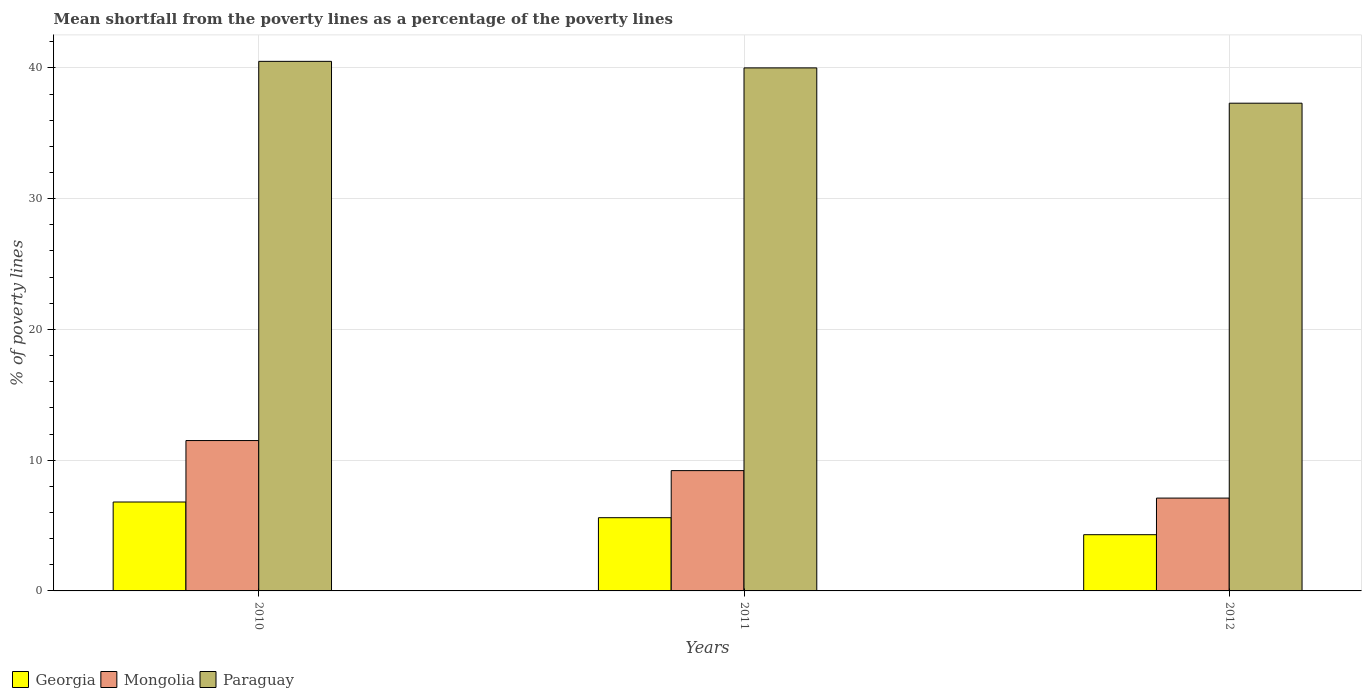How many different coloured bars are there?
Make the answer very short. 3. How many bars are there on the 1st tick from the left?
Give a very brief answer. 3. How many bars are there on the 1st tick from the right?
Keep it short and to the point. 3. Across all years, what is the maximum mean shortfall from the poverty lines as a percentage of the poverty lines in Georgia?
Provide a short and direct response. 6.8. Across all years, what is the minimum mean shortfall from the poverty lines as a percentage of the poverty lines in Mongolia?
Make the answer very short. 7.1. What is the total mean shortfall from the poverty lines as a percentage of the poverty lines in Paraguay in the graph?
Give a very brief answer. 117.8. What is the difference between the mean shortfall from the poverty lines as a percentage of the poverty lines in Paraguay in 2010 and that in 2011?
Provide a short and direct response. 0.5. What is the average mean shortfall from the poverty lines as a percentage of the poverty lines in Mongolia per year?
Ensure brevity in your answer.  9.27. In the year 2011, what is the difference between the mean shortfall from the poverty lines as a percentage of the poverty lines in Georgia and mean shortfall from the poverty lines as a percentage of the poverty lines in Mongolia?
Provide a short and direct response. -3.6. Is the mean shortfall from the poverty lines as a percentage of the poverty lines in Mongolia in 2011 less than that in 2012?
Your answer should be compact. No. Is the difference between the mean shortfall from the poverty lines as a percentage of the poverty lines in Georgia in 2010 and 2011 greater than the difference between the mean shortfall from the poverty lines as a percentage of the poverty lines in Mongolia in 2010 and 2011?
Offer a very short reply. No. What is the difference between the highest and the second highest mean shortfall from the poverty lines as a percentage of the poverty lines in Georgia?
Provide a succinct answer. 1.2. What is the difference between the highest and the lowest mean shortfall from the poverty lines as a percentage of the poverty lines in Paraguay?
Offer a terse response. 3.2. In how many years, is the mean shortfall from the poverty lines as a percentage of the poverty lines in Georgia greater than the average mean shortfall from the poverty lines as a percentage of the poverty lines in Georgia taken over all years?
Your answer should be compact. 2. Is the sum of the mean shortfall from the poverty lines as a percentage of the poverty lines in Georgia in 2010 and 2011 greater than the maximum mean shortfall from the poverty lines as a percentage of the poverty lines in Paraguay across all years?
Offer a terse response. No. What does the 2nd bar from the left in 2010 represents?
Provide a succinct answer. Mongolia. What does the 3rd bar from the right in 2011 represents?
Provide a short and direct response. Georgia. How many bars are there?
Keep it short and to the point. 9. Are all the bars in the graph horizontal?
Your response must be concise. No. How many years are there in the graph?
Keep it short and to the point. 3. Does the graph contain any zero values?
Provide a succinct answer. No. How many legend labels are there?
Provide a succinct answer. 3. How are the legend labels stacked?
Give a very brief answer. Horizontal. What is the title of the graph?
Your answer should be compact. Mean shortfall from the poverty lines as a percentage of the poverty lines. What is the label or title of the Y-axis?
Your answer should be compact. % of poverty lines. What is the % of poverty lines of Georgia in 2010?
Keep it short and to the point. 6.8. What is the % of poverty lines of Paraguay in 2010?
Give a very brief answer. 40.5. What is the % of poverty lines of Mongolia in 2012?
Offer a very short reply. 7.1. What is the % of poverty lines of Paraguay in 2012?
Make the answer very short. 37.3. Across all years, what is the maximum % of poverty lines of Georgia?
Offer a very short reply. 6.8. Across all years, what is the maximum % of poverty lines of Paraguay?
Make the answer very short. 40.5. Across all years, what is the minimum % of poverty lines in Georgia?
Your response must be concise. 4.3. Across all years, what is the minimum % of poverty lines of Paraguay?
Offer a terse response. 37.3. What is the total % of poverty lines of Mongolia in the graph?
Offer a very short reply. 27.8. What is the total % of poverty lines of Paraguay in the graph?
Make the answer very short. 117.8. What is the difference between the % of poverty lines in Georgia in 2010 and that in 2011?
Your response must be concise. 1.2. What is the difference between the % of poverty lines in Paraguay in 2010 and that in 2011?
Your response must be concise. 0.5. What is the difference between the % of poverty lines of Georgia in 2010 and that in 2012?
Offer a very short reply. 2.5. What is the difference between the % of poverty lines of Georgia in 2010 and the % of poverty lines of Mongolia in 2011?
Give a very brief answer. -2.4. What is the difference between the % of poverty lines of Georgia in 2010 and the % of poverty lines of Paraguay in 2011?
Make the answer very short. -33.2. What is the difference between the % of poverty lines of Mongolia in 2010 and the % of poverty lines of Paraguay in 2011?
Your answer should be compact. -28.5. What is the difference between the % of poverty lines in Georgia in 2010 and the % of poverty lines in Paraguay in 2012?
Give a very brief answer. -30.5. What is the difference between the % of poverty lines of Mongolia in 2010 and the % of poverty lines of Paraguay in 2012?
Your answer should be very brief. -25.8. What is the difference between the % of poverty lines of Georgia in 2011 and the % of poverty lines of Mongolia in 2012?
Give a very brief answer. -1.5. What is the difference between the % of poverty lines of Georgia in 2011 and the % of poverty lines of Paraguay in 2012?
Provide a short and direct response. -31.7. What is the difference between the % of poverty lines of Mongolia in 2011 and the % of poverty lines of Paraguay in 2012?
Offer a terse response. -28.1. What is the average % of poverty lines of Georgia per year?
Keep it short and to the point. 5.57. What is the average % of poverty lines in Mongolia per year?
Make the answer very short. 9.27. What is the average % of poverty lines in Paraguay per year?
Your response must be concise. 39.27. In the year 2010, what is the difference between the % of poverty lines of Georgia and % of poverty lines of Mongolia?
Your answer should be compact. -4.7. In the year 2010, what is the difference between the % of poverty lines of Georgia and % of poverty lines of Paraguay?
Make the answer very short. -33.7. In the year 2010, what is the difference between the % of poverty lines in Mongolia and % of poverty lines in Paraguay?
Offer a very short reply. -29. In the year 2011, what is the difference between the % of poverty lines in Georgia and % of poverty lines in Mongolia?
Your answer should be very brief. -3.6. In the year 2011, what is the difference between the % of poverty lines in Georgia and % of poverty lines in Paraguay?
Offer a very short reply. -34.4. In the year 2011, what is the difference between the % of poverty lines in Mongolia and % of poverty lines in Paraguay?
Provide a short and direct response. -30.8. In the year 2012, what is the difference between the % of poverty lines of Georgia and % of poverty lines of Paraguay?
Your answer should be compact. -33. In the year 2012, what is the difference between the % of poverty lines of Mongolia and % of poverty lines of Paraguay?
Ensure brevity in your answer.  -30.2. What is the ratio of the % of poverty lines in Georgia in 2010 to that in 2011?
Give a very brief answer. 1.21. What is the ratio of the % of poverty lines of Mongolia in 2010 to that in 2011?
Provide a short and direct response. 1.25. What is the ratio of the % of poverty lines in Paraguay in 2010 to that in 2011?
Keep it short and to the point. 1.01. What is the ratio of the % of poverty lines in Georgia in 2010 to that in 2012?
Your response must be concise. 1.58. What is the ratio of the % of poverty lines of Mongolia in 2010 to that in 2012?
Offer a terse response. 1.62. What is the ratio of the % of poverty lines in Paraguay in 2010 to that in 2012?
Keep it short and to the point. 1.09. What is the ratio of the % of poverty lines in Georgia in 2011 to that in 2012?
Keep it short and to the point. 1.3. What is the ratio of the % of poverty lines in Mongolia in 2011 to that in 2012?
Offer a terse response. 1.3. What is the ratio of the % of poverty lines in Paraguay in 2011 to that in 2012?
Ensure brevity in your answer.  1.07. What is the difference between the highest and the second highest % of poverty lines in Georgia?
Keep it short and to the point. 1.2. What is the difference between the highest and the second highest % of poverty lines of Mongolia?
Offer a very short reply. 2.3. What is the difference between the highest and the lowest % of poverty lines in Georgia?
Your answer should be compact. 2.5. What is the difference between the highest and the lowest % of poverty lines in Mongolia?
Your response must be concise. 4.4. 